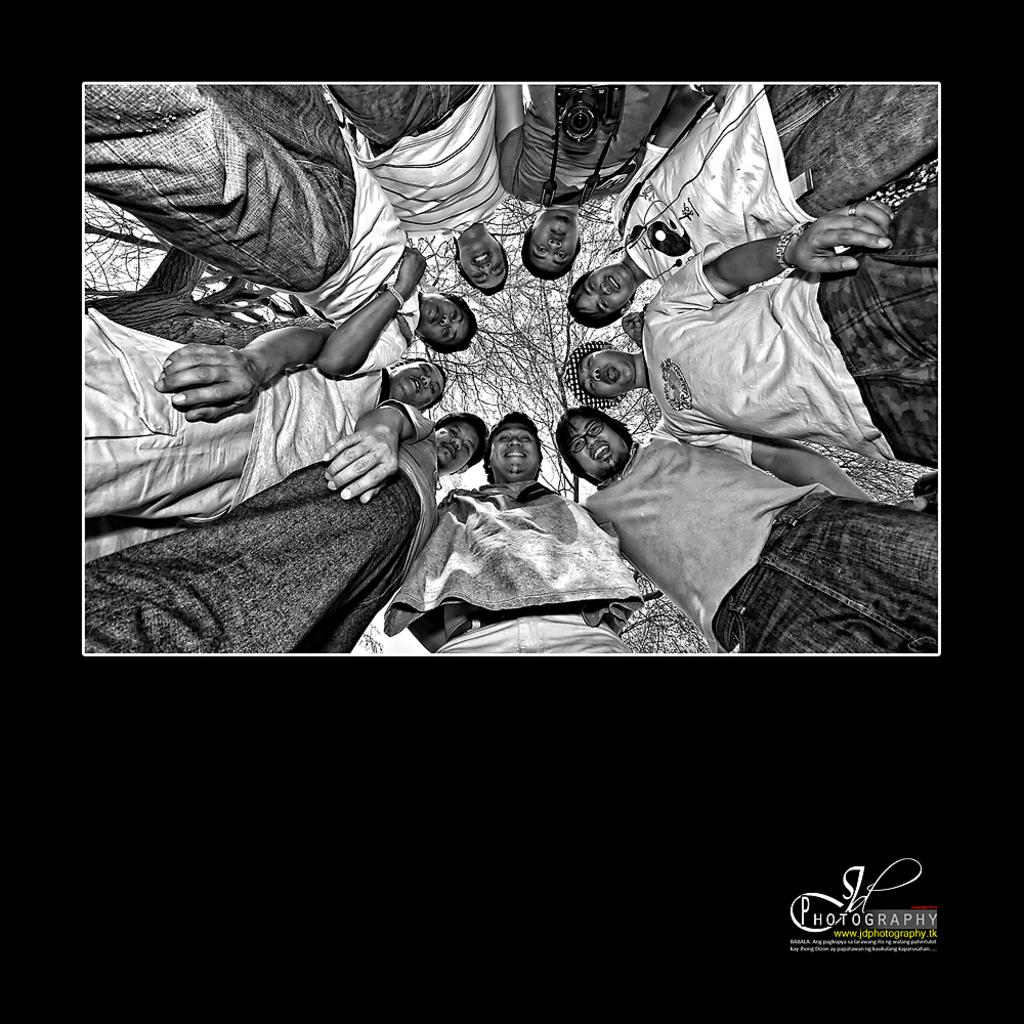Who or what can be seen in the image? There are people in the image. What type of natural environment is present in the image? There are trees in the image. Is there any additional information or marking in the image? Yes, there is a watermark in the bottom right corner of the image. What type of ornament is hanging from the tree in the image? There is no ornament hanging from the tree in the image; only people and trees are present. Can you describe the cave that is visible in the image? There is no cave present in the image. 